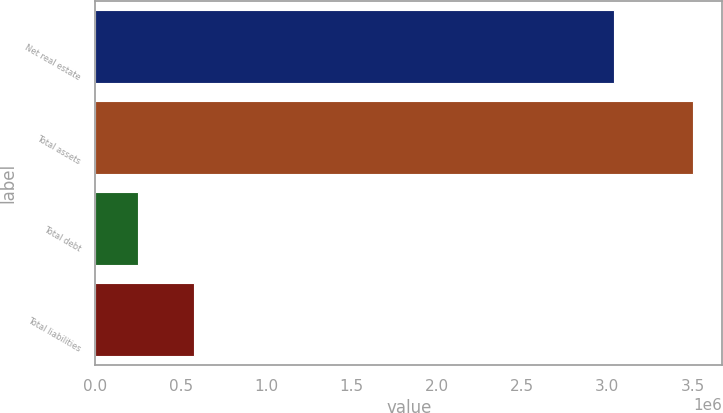Convert chart. <chart><loc_0><loc_0><loc_500><loc_500><bar_chart><fcel>Net real estate<fcel>Total assets<fcel>Total debt<fcel>Total liabilities<nl><fcel>3.0409e+06<fcel>3.49948e+06<fcel>251047<fcel>575890<nl></chart> 